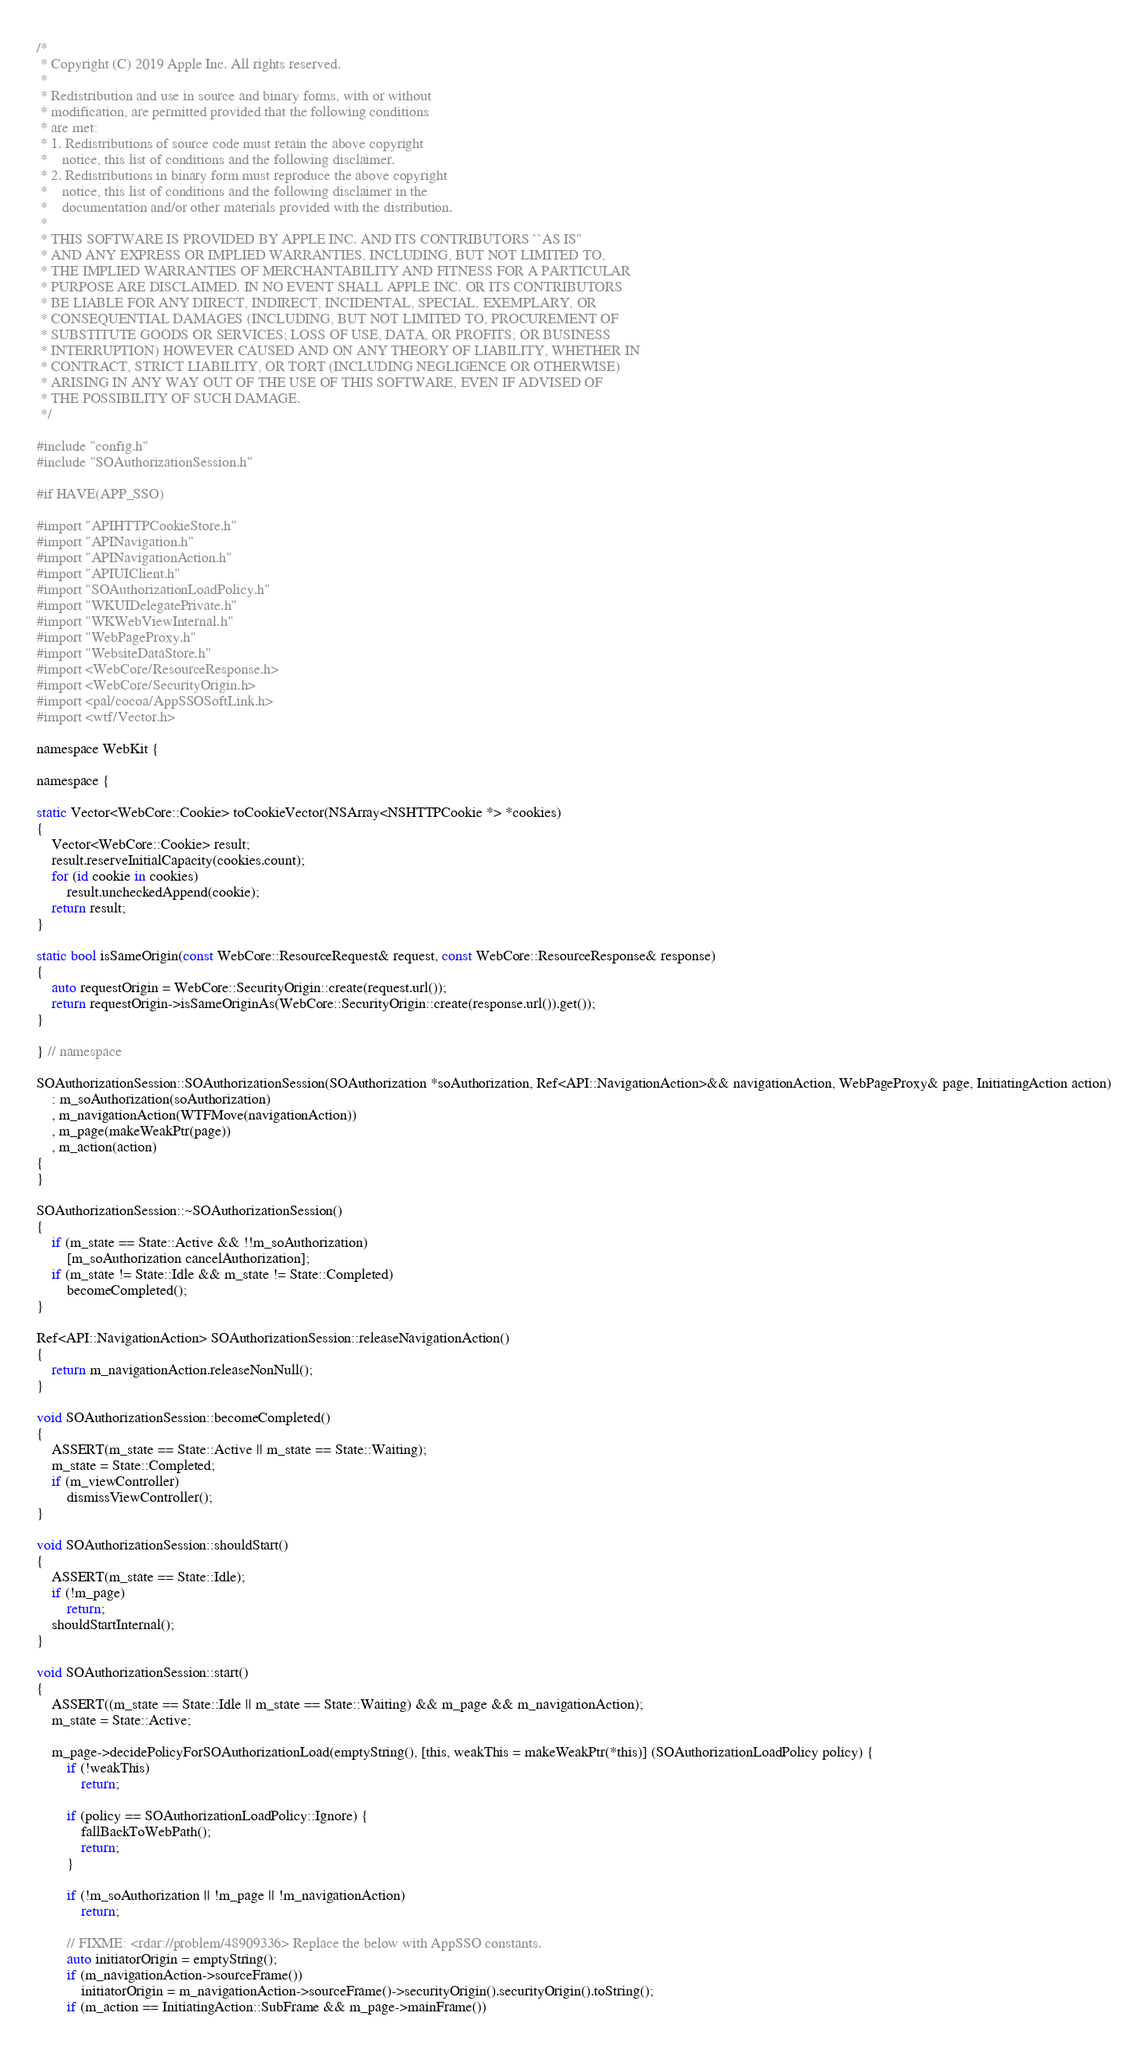<code> <loc_0><loc_0><loc_500><loc_500><_ObjectiveC_>/*
 * Copyright (C) 2019 Apple Inc. All rights reserved.
 *
 * Redistribution and use in source and binary forms, with or without
 * modification, are permitted provided that the following conditions
 * are met:
 * 1. Redistributions of source code must retain the above copyright
 *    notice, this list of conditions and the following disclaimer.
 * 2. Redistributions in binary form must reproduce the above copyright
 *    notice, this list of conditions and the following disclaimer in the
 *    documentation and/or other materials provided with the distribution.
 *
 * THIS SOFTWARE IS PROVIDED BY APPLE INC. AND ITS CONTRIBUTORS ``AS IS''
 * AND ANY EXPRESS OR IMPLIED WARRANTIES, INCLUDING, BUT NOT LIMITED TO,
 * THE IMPLIED WARRANTIES OF MERCHANTABILITY AND FITNESS FOR A PARTICULAR
 * PURPOSE ARE DISCLAIMED. IN NO EVENT SHALL APPLE INC. OR ITS CONTRIBUTORS
 * BE LIABLE FOR ANY DIRECT, INDIRECT, INCIDENTAL, SPECIAL, EXEMPLARY, OR
 * CONSEQUENTIAL DAMAGES (INCLUDING, BUT NOT LIMITED TO, PROCUREMENT OF
 * SUBSTITUTE GOODS OR SERVICES; LOSS OF USE, DATA, OR PROFITS; OR BUSINESS
 * INTERRUPTION) HOWEVER CAUSED AND ON ANY THEORY OF LIABILITY, WHETHER IN
 * CONTRACT, STRICT LIABILITY, OR TORT (INCLUDING NEGLIGENCE OR OTHERWISE)
 * ARISING IN ANY WAY OUT OF THE USE OF THIS SOFTWARE, EVEN IF ADVISED OF
 * THE POSSIBILITY OF SUCH DAMAGE.
 */

#include "config.h"
#include "SOAuthorizationSession.h"

#if HAVE(APP_SSO)

#import "APIHTTPCookieStore.h"
#import "APINavigation.h"
#import "APINavigationAction.h"
#import "APIUIClient.h"
#import "SOAuthorizationLoadPolicy.h"
#import "WKUIDelegatePrivate.h"
#import "WKWebViewInternal.h"
#import "WebPageProxy.h"
#import "WebsiteDataStore.h"
#import <WebCore/ResourceResponse.h>
#import <WebCore/SecurityOrigin.h>
#import <pal/cocoa/AppSSOSoftLink.h>
#import <wtf/Vector.h>

namespace WebKit {

namespace {

static Vector<WebCore::Cookie> toCookieVector(NSArray<NSHTTPCookie *> *cookies)
{
    Vector<WebCore::Cookie> result;
    result.reserveInitialCapacity(cookies.count);
    for (id cookie in cookies)
        result.uncheckedAppend(cookie);
    return result;
}

static bool isSameOrigin(const WebCore::ResourceRequest& request, const WebCore::ResourceResponse& response)
{
    auto requestOrigin = WebCore::SecurityOrigin::create(request.url());
    return requestOrigin->isSameOriginAs(WebCore::SecurityOrigin::create(response.url()).get());
}

} // namespace

SOAuthorizationSession::SOAuthorizationSession(SOAuthorization *soAuthorization, Ref<API::NavigationAction>&& navigationAction, WebPageProxy& page, InitiatingAction action)
    : m_soAuthorization(soAuthorization)
    , m_navigationAction(WTFMove(navigationAction))
    , m_page(makeWeakPtr(page))
    , m_action(action)
{
}

SOAuthorizationSession::~SOAuthorizationSession()
{
    if (m_state == State::Active && !!m_soAuthorization)
        [m_soAuthorization cancelAuthorization];
    if (m_state != State::Idle && m_state != State::Completed)
        becomeCompleted();
}

Ref<API::NavigationAction> SOAuthorizationSession::releaseNavigationAction()
{
    return m_navigationAction.releaseNonNull();
}

void SOAuthorizationSession::becomeCompleted()
{
    ASSERT(m_state == State::Active || m_state == State::Waiting);
    m_state = State::Completed;
    if (m_viewController)
        dismissViewController();
}

void SOAuthorizationSession::shouldStart()
{
    ASSERT(m_state == State::Idle);
    if (!m_page)
        return;
    shouldStartInternal();
}

void SOAuthorizationSession::start()
{
    ASSERT((m_state == State::Idle || m_state == State::Waiting) && m_page && m_navigationAction);
    m_state = State::Active;

    m_page->decidePolicyForSOAuthorizationLoad(emptyString(), [this, weakThis = makeWeakPtr(*this)] (SOAuthorizationLoadPolicy policy) {
        if (!weakThis)
            return;

        if (policy == SOAuthorizationLoadPolicy::Ignore) {
            fallBackToWebPath();
            return;
        }

        if (!m_soAuthorization || !m_page || !m_navigationAction)
            return;

        // FIXME: <rdar://problem/48909336> Replace the below with AppSSO constants.
        auto initiatorOrigin = emptyString();
        if (m_navigationAction->sourceFrame())
            initiatorOrigin = m_navigationAction->sourceFrame()->securityOrigin().securityOrigin().toString();
        if (m_action == InitiatingAction::SubFrame && m_page->mainFrame())</code> 